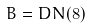Convert formula to latex. <formula><loc_0><loc_0><loc_500><loc_500>B = D N ( 8 )</formula> 